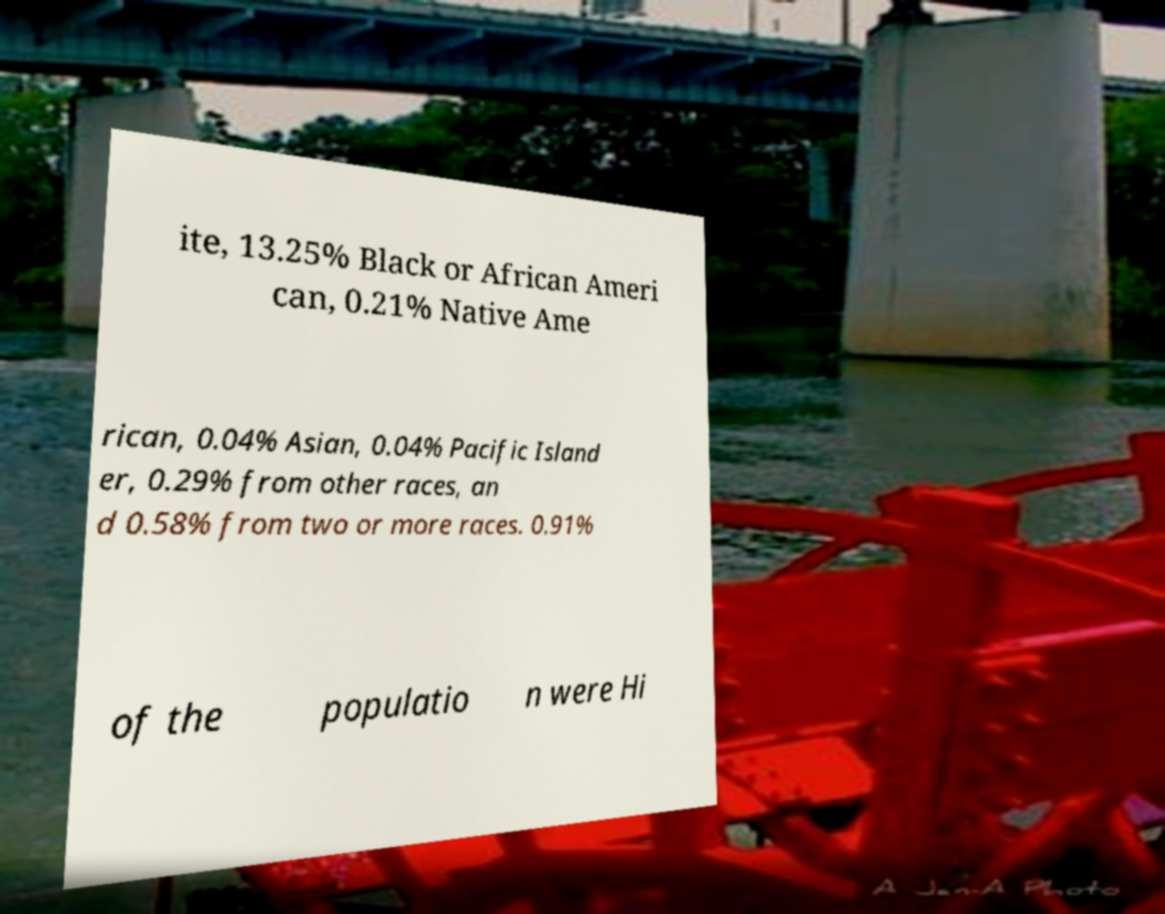Please identify and transcribe the text found in this image. ite, 13.25% Black or African Ameri can, 0.21% Native Ame rican, 0.04% Asian, 0.04% Pacific Island er, 0.29% from other races, an d 0.58% from two or more races. 0.91% of the populatio n were Hi 